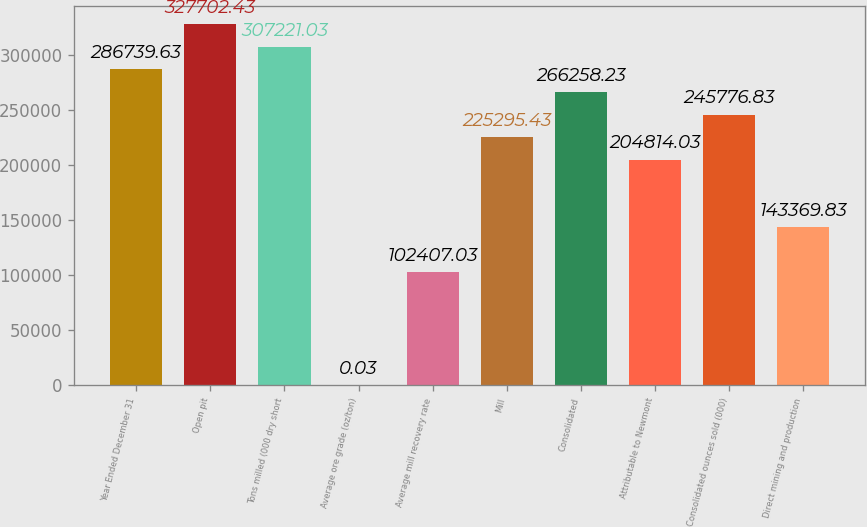Convert chart. <chart><loc_0><loc_0><loc_500><loc_500><bar_chart><fcel>Year Ended December 31<fcel>Open pit<fcel>Tons milled (000 dry short<fcel>Average ore grade (oz/ton)<fcel>Average mill recovery rate<fcel>Mill<fcel>Consolidated<fcel>Attributable to Newmont<fcel>Consolidated ounces sold (000)<fcel>Direct mining and production<nl><fcel>286740<fcel>327702<fcel>307221<fcel>0.03<fcel>102407<fcel>225295<fcel>266258<fcel>204814<fcel>245777<fcel>143370<nl></chart> 